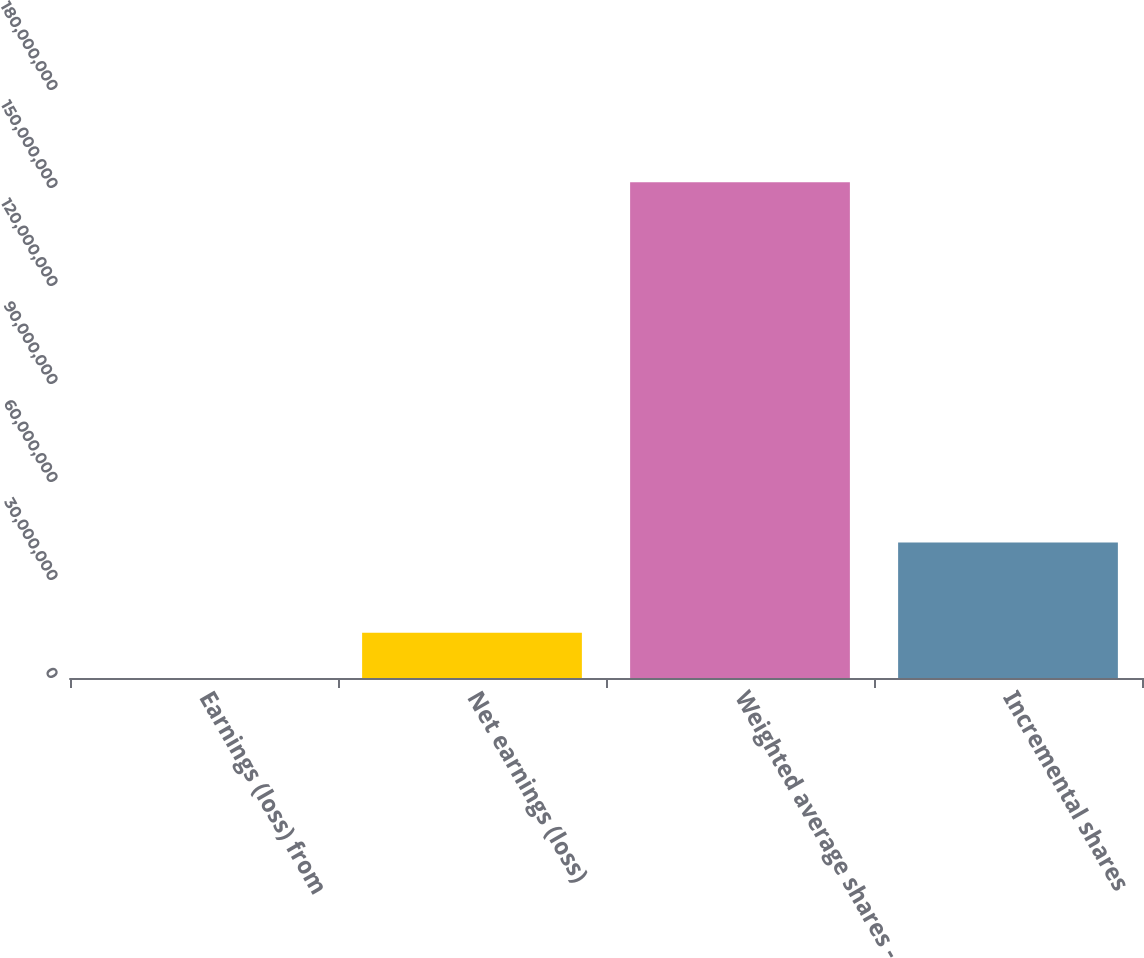<chart> <loc_0><loc_0><loc_500><loc_500><bar_chart><fcel>Earnings (loss) from<fcel>Net earnings (loss)<fcel>Weighted average shares -<fcel>Incremental shares<nl><fcel>13<fcel>1.38318e+07<fcel>1.51734e+08<fcel>4.14952e+07<nl></chart> 